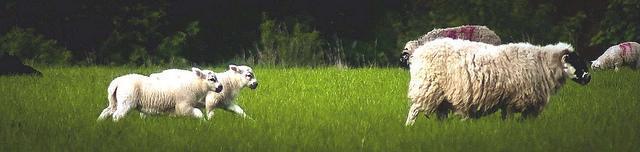How many goats are in the picture?
Give a very brief answer. 0. How many sheep are in the picture?
Give a very brief answer. 2. 